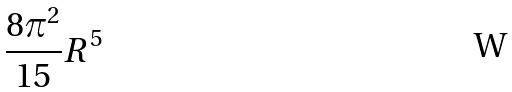<formula> <loc_0><loc_0><loc_500><loc_500>\frac { 8 \pi ^ { 2 } } { 1 5 } R ^ { 5 }</formula> 